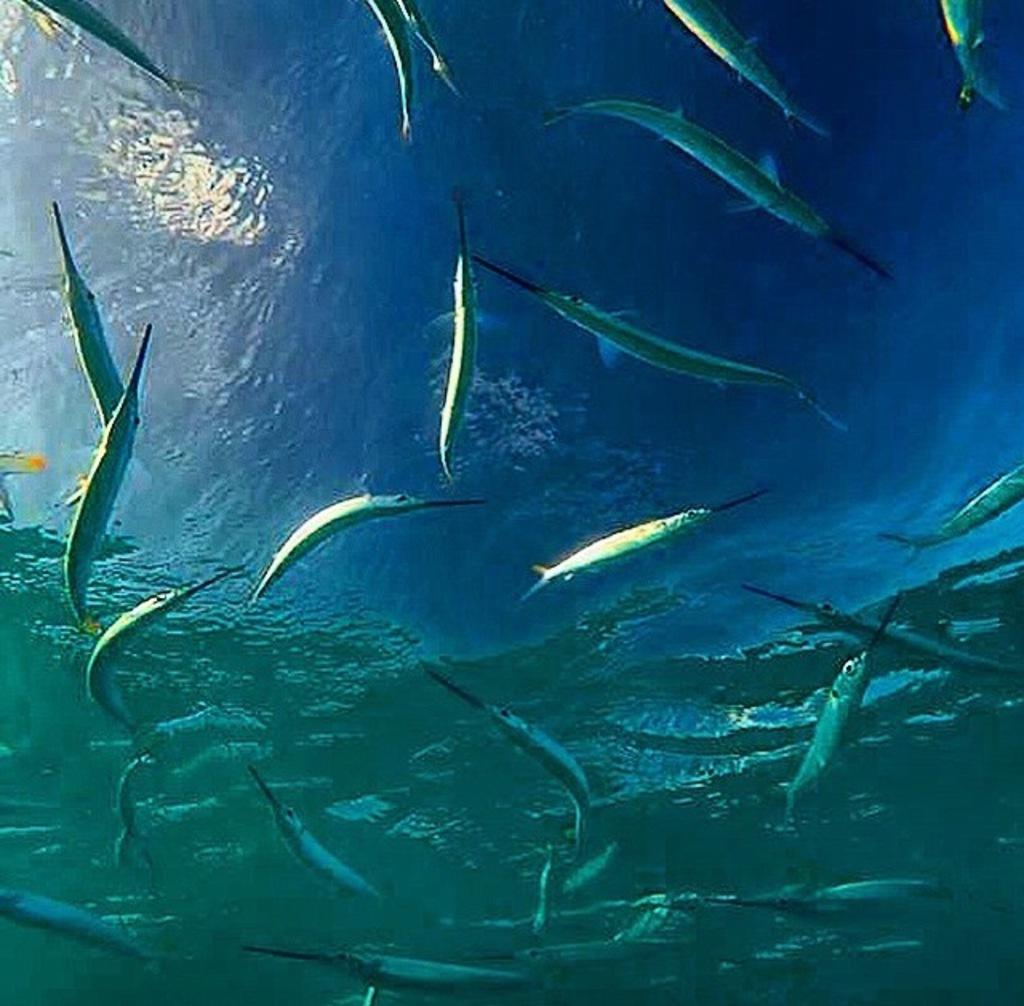What type of animals can be seen in the image? There are fishes in the image. What are the fishes doing in the image? The fishes are swimming in the water. Can you describe the environment in which the fishes are swimming? The water could be in the sea or in an aquarium, but this information is not definitive based on the transcript. What type of yoke can be seen attached to the fishes in the image? There is no yoke present in the image; it features fishes swimming in the water. Can you describe the zipper on the doll in the image? There is no doll present in the image, only fishes swimming in the water. 